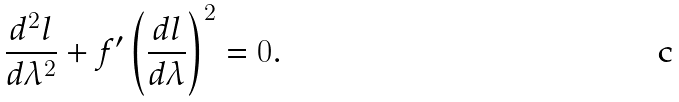<formula> <loc_0><loc_0><loc_500><loc_500>\frac { d ^ { 2 } l } { d \lambda ^ { 2 } } + f ^ { \prime } \left ( \frac { d l } { d \lambda } \right ) ^ { 2 } = 0 .</formula> 